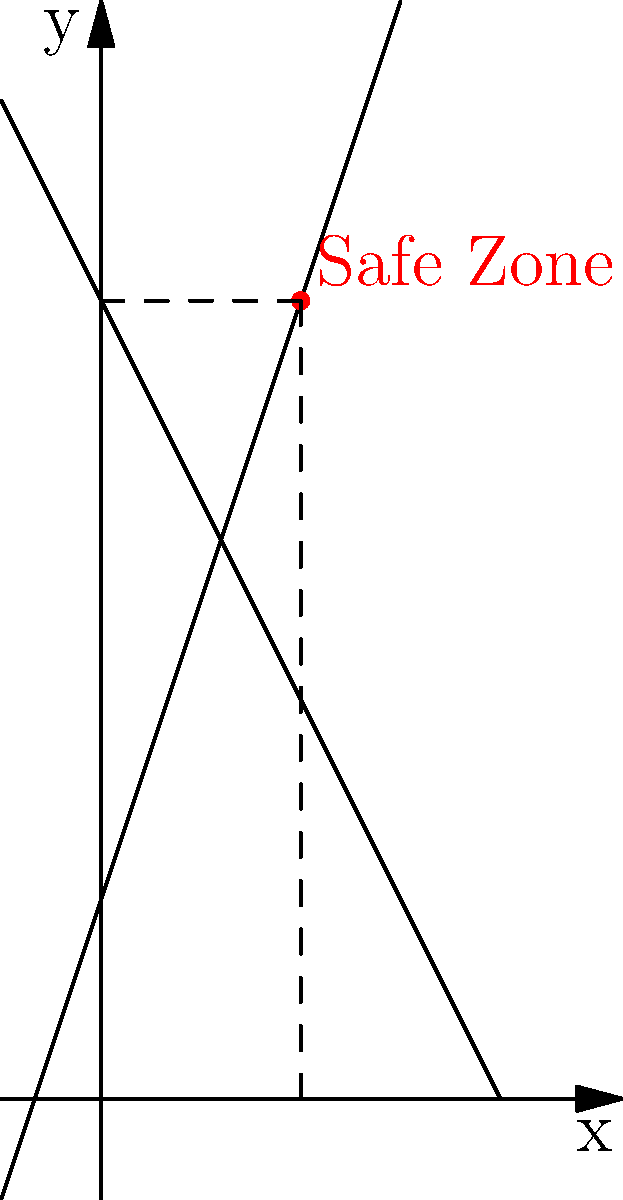A safe zone for vulnerable populations is defined by the intersection of two boundary lines on a coordinate plane. The first boundary is represented by the equation $y = 3x + 2$, and the second boundary is represented by $y = -2x + 8$. Calculate the coordinates of the point where these boundaries intersect to determine the center of the safe zone. To find the intersection point of the two lines, we need to solve the system of equations:

1) $y = 3x + 2$
2) $y = -2x + 8$

Step 1: Set the equations equal to each other since they both equal y.
$3x + 2 = -2x + 8$

Step 2: Solve for x by adding 2x to both sides and subtracting 2 from both sides.
$5x = 6$

Step 3: Divide both sides by 5 to isolate x.
$x = \frac{6}{5} = 1.2$

Step 4: Substitute this x-value into either of the original equations. Let's use the first one:
$y = 3(1.2) + 2$
$y = 3.6 + 2 = 5.6$

Step 5: The intersection point, which is the center of the safe zone, is $(1.2, 5.6)$.

Step 6: For the purpose of practical implementation, we can round these values to the nearest whole number:
$(1.2, 5.6) \approx (1, 6)$
Answer: $(1, 6)$ 